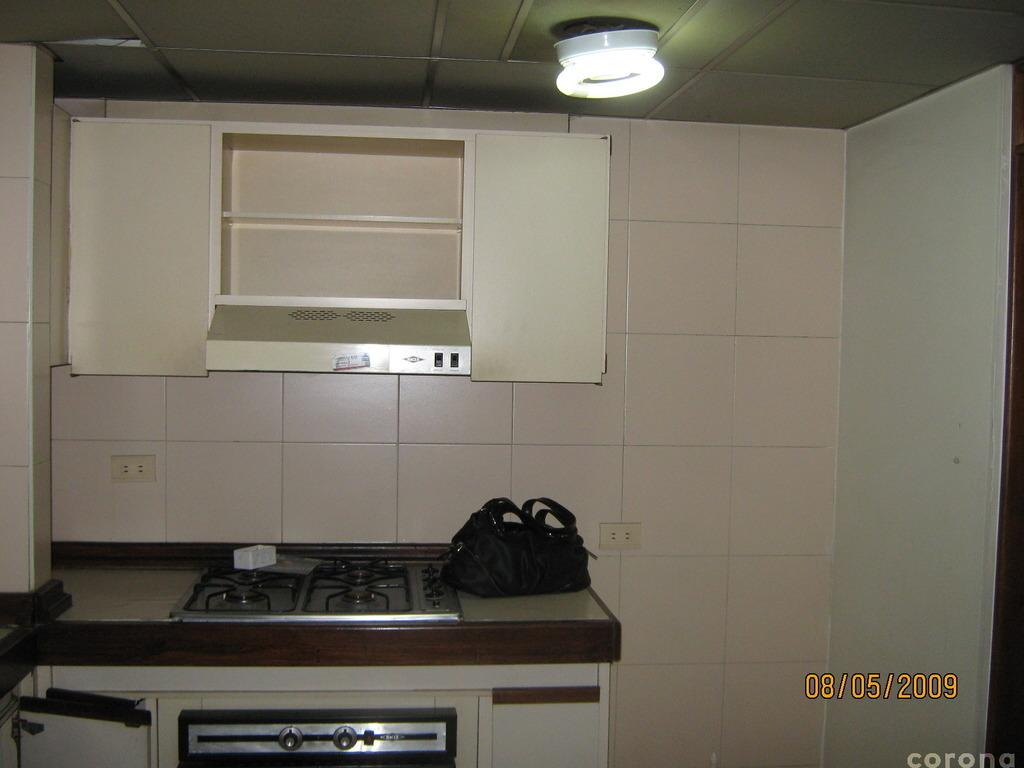What type of room is depicted in the image? The image is of a kitchen. What is a feature of the kitchen that is typically used for ventilation? There is a chimney in the kitchen. What is a common appliance found in kitchens for cooking? There is a stove in the kitchen. What is an object in the kitchen that might be used for carrying or storing items? There is a bag in the kitchen. What is another appliance in the kitchen that can be used for heating food? There is a microwave oven in the kitchen. What is a source of light in the kitchen? There is a light in the kitchen. What is the value of the voyage depicted in the image? There is no voyage depicted in the image; it is a picture of a kitchen. What is the income of the person who owns the kitchen in the image? The image does not provide any information about the income of the person who owns the kitchen. 